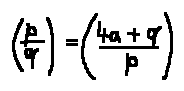Convert formula to latex. <formula><loc_0><loc_0><loc_500><loc_500>( \frac { p } { q } ) = ( \frac { 4 a + q } { p } )</formula> 